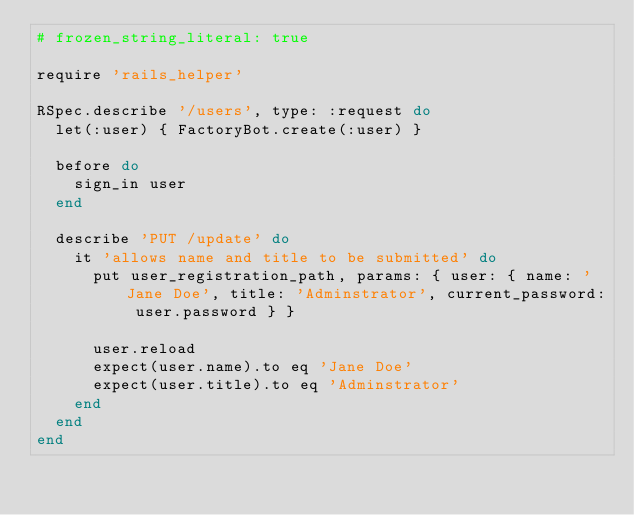<code> <loc_0><loc_0><loc_500><loc_500><_Ruby_># frozen_string_literal: true

require 'rails_helper'

RSpec.describe '/users', type: :request do
  let(:user) { FactoryBot.create(:user) }

  before do
    sign_in user
  end

  describe 'PUT /update' do
    it 'allows name and title to be submitted' do
      put user_registration_path, params: { user: { name: 'Jane Doe', title: 'Adminstrator', current_password: user.password } }

      user.reload
      expect(user.name).to eq 'Jane Doe'
      expect(user.title).to eq 'Adminstrator'
    end
  end
end
</code> 